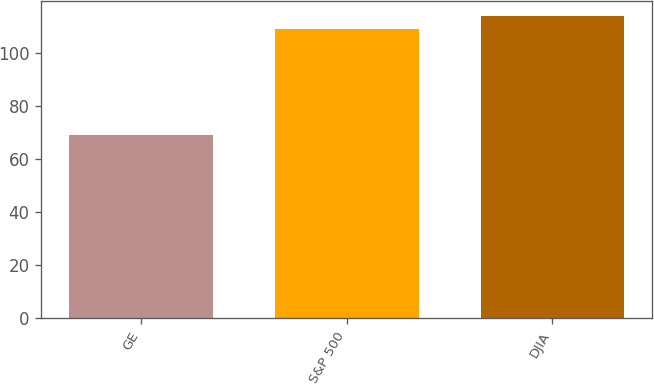Convert chart. <chart><loc_0><loc_0><loc_500><loc_500><bar_chart><fcel>GE<fcel>S&P 500<fcel>DJIA<nl><fcel>69<fcel>109<fcel>114<nl></chart> 